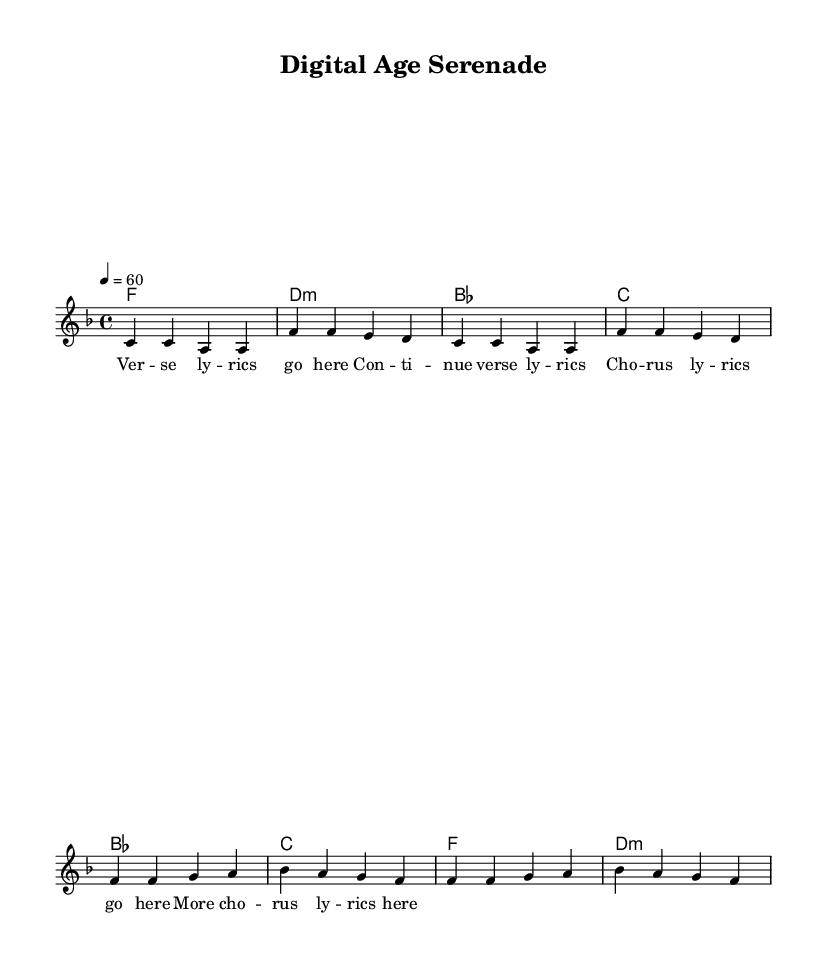What is the key signature of this music? The key signature is F major, which contains one flat (B flat).
Answer: F major What is the time signature of this music? The time signature is 4/4, meaning there are four beats in each measure.
Answer: 4/4 What is the tempo marking given in the score? The tempo marking indicates a speed of 60 beats per minute, denoted by "4 = 60."
Answer: 60 How many measures are there in the verse section? The verse consists of 4 measures, as indicated by the grouped notes in the sheet.
Answer: 4 measures What type of chord is used in measure 2 of the verse? Measure 2 contains a D minor chord, which is indicated by "d:m" in the harmonies.
Answer: D minor What is the structure of the song based on the lyrics and music? The song follows a verse-chorus structure, typical of R&B ballads, alternating between lyrics for verse and chorus sections.
Answer: Verse-Chorus What style of music is represented by this score? The music is categorized as Rhythm and Blues (R&B), particularly focusing on ballads that reflect emotional themes.
Answer: Rhythm and Blues 